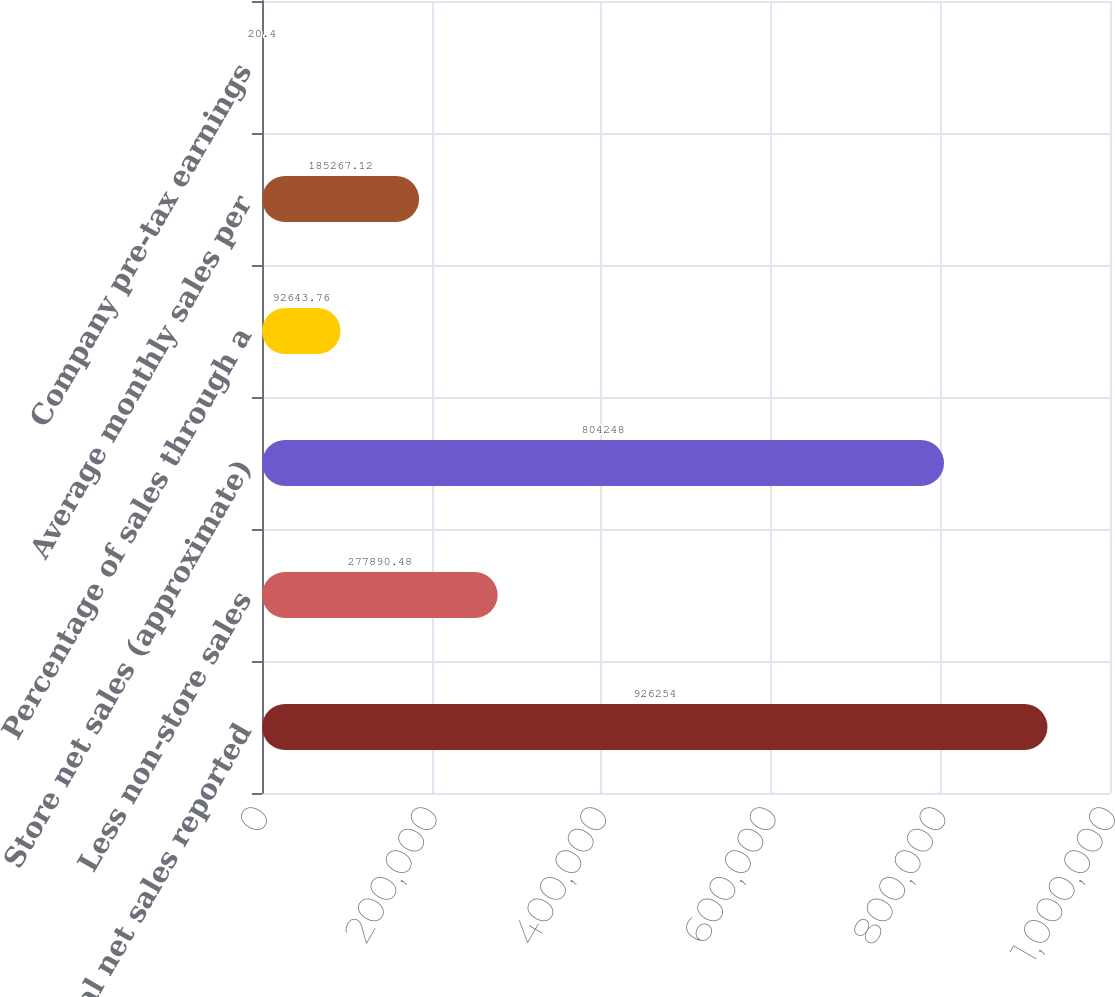<chart> <loc_0><loc_0><loc_500><loc_500><bar_chart><fcel>Total net sales reported<fcel>Less non-store sales<fcel>Store net sales (approximate)<fcel>Percentage of sales through a<fcel>Average monthly sales per<fcel>Company pre-tax earnings<nl><fcel>926254<fcel>277890<fcel>804248<fcel>92643.8<fcel>185267<fcel>20.4<nl></chart> 